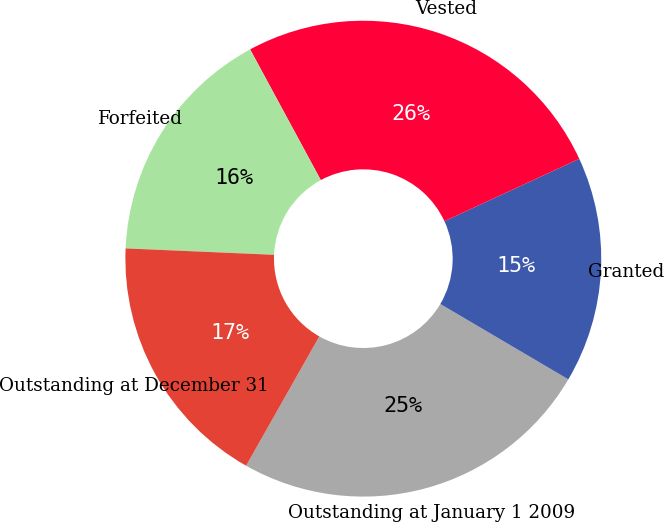Convert chart to OTSL. <chart><loc_0><loc_0><loc_500><loc_500><pie_chart><fcel>Outstanding at January 1 2009<fcel>Granted<fcel>Vested<fcel>Forfeited<fcel>Outstanding at December 31<nl><fcel>24.73%<fcel>15.36%<fcel>26.0%<fcel>16.42%<fcel>17.49%<nl></chart> 